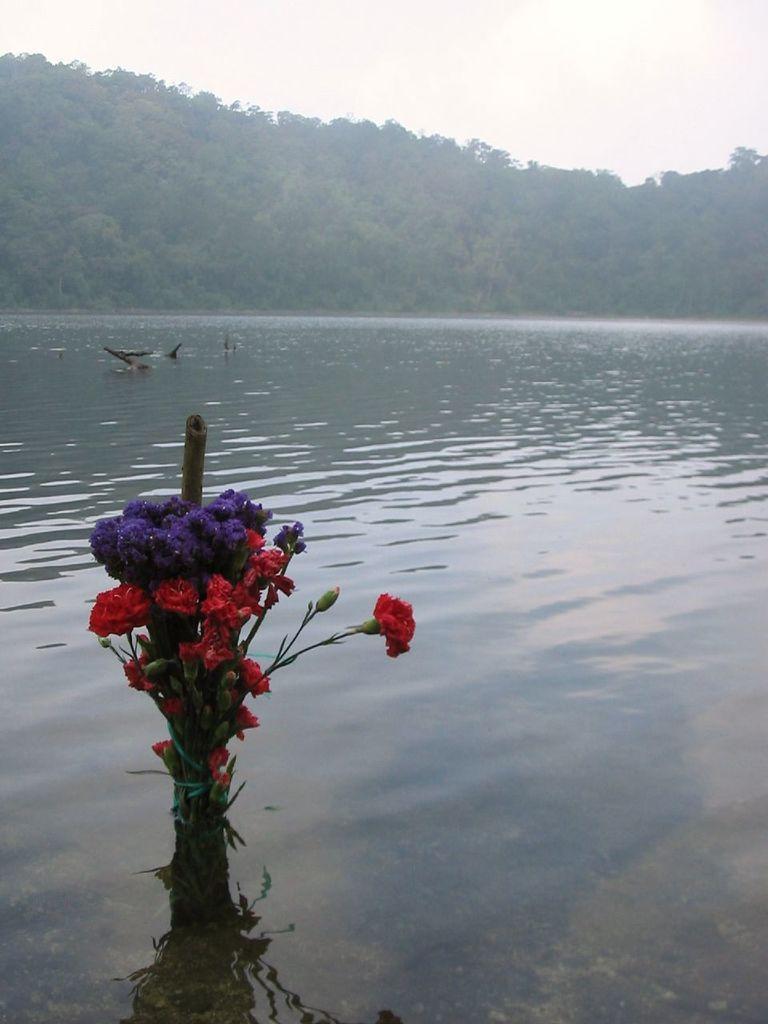Please provide a concise description of this image. There is a river and a fish is swimming in the river and in the front there is a beautiful flower plant with different colors of flowers to it,in the background there are lot of trees. 